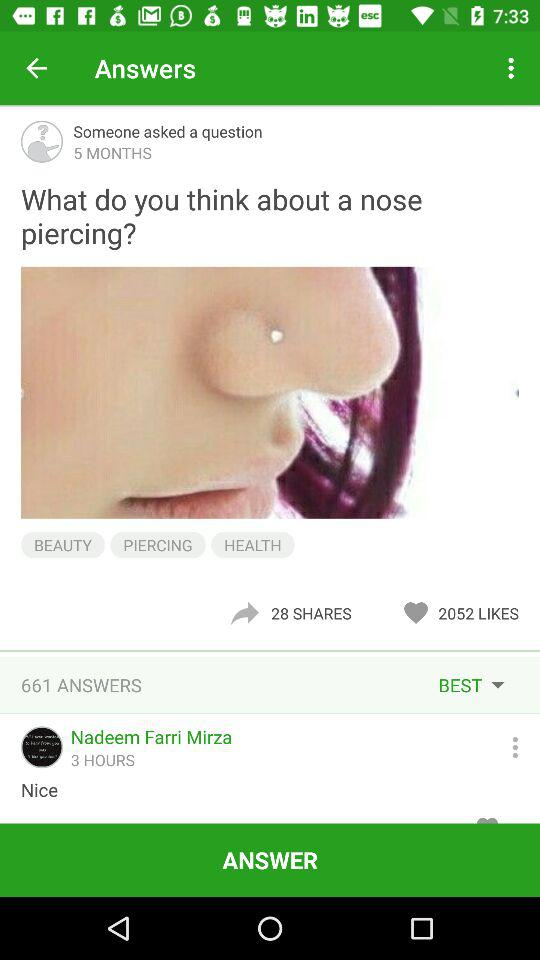How many more people answered this question than shared it?
Answer the question using a single word or phrase. 633 